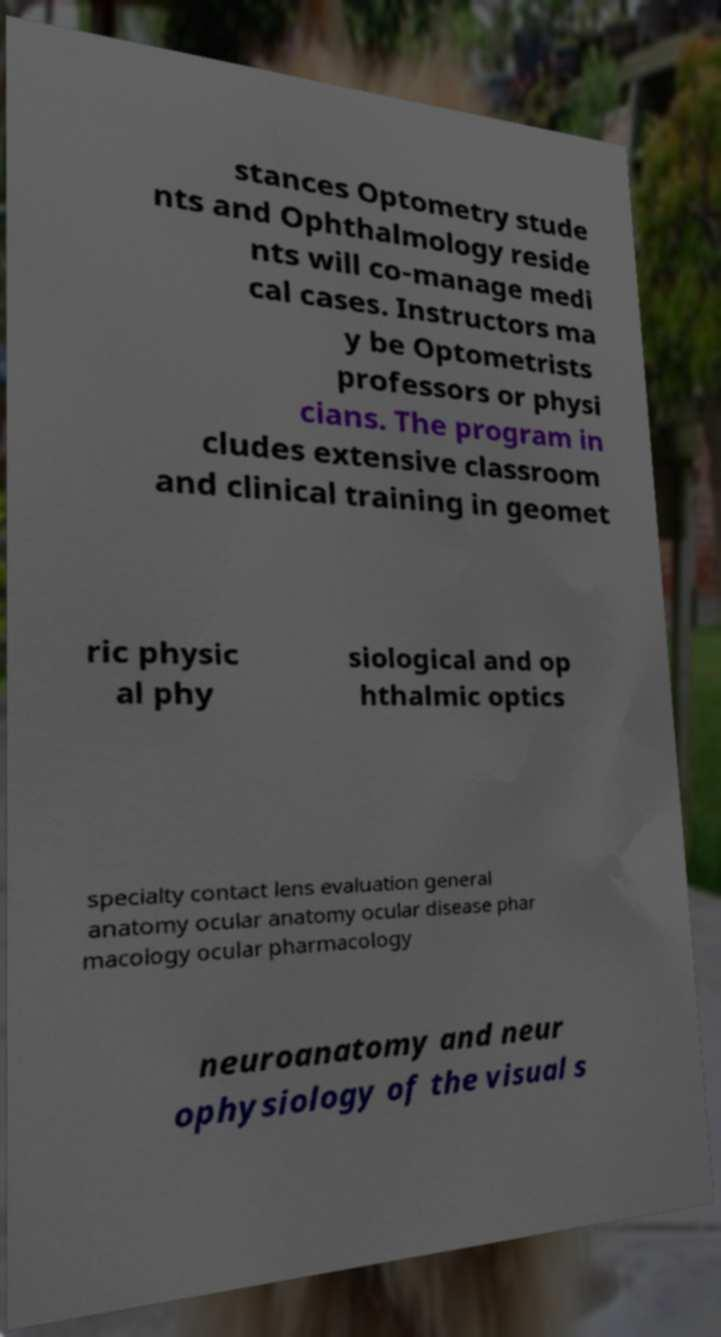Can you read and provide the text displayed in the image?This photo seems to have some interesting text. Can you extract and type it out for me? stances Optometry stude nts and Ophthalmology reside nts will co-manage medi cal cases. Instructors ma y be Optometrists professors or physi cians. The program in cludes extensive classroom and clinical training in geomet ric physic al phy siological and op hthalmic optics specialty contact lens evaluation general anatomy ocular anatomy ocular disease phar macology ocular pharmacology neuroanatomy and neur ophysiology of the visual s 